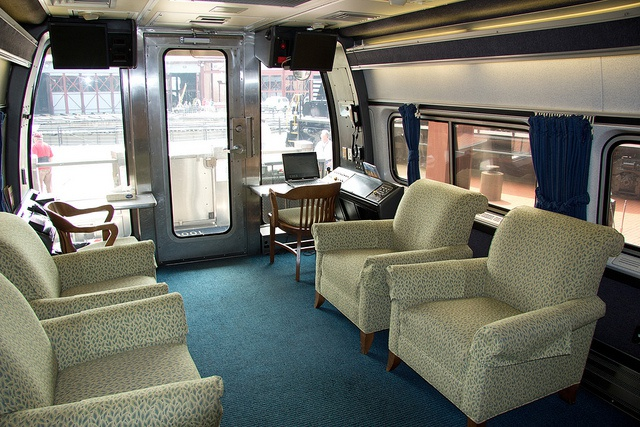Describe the objects in this image and their specific colors. I can see train in gray, black, white, and darkgray tones, chair in black, gray, and darkgreen tones, chair in black, gray, and darkgray tones, chair in black, gray, tan, and darkgreen tones, and chair in black, gray, darkgray, and beige tones in this image. 